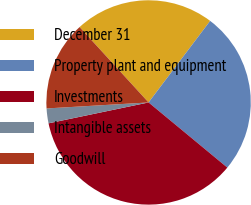Convert chart. <chart><loc_0><loc_0><loc_500><loc_500><pie_chart><fcel>December 31<fcel>Property plant and equipment<fcel>Investments<fcel>Intangible assets<fcel>Goodwill<nl><fcel>22.09%<fcel>25.71%<fcel>35.73%<fcel>2.34%<fcel>14.14%<nl></chart> 